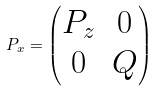Convert formula to latex. <formula><loc_0><loc_0><loc_500><loc_500>P _ { x } = \begin{pmatrix} P _ { z } & 0 \\ 0 & Q \end{pmatrix}</formula> 